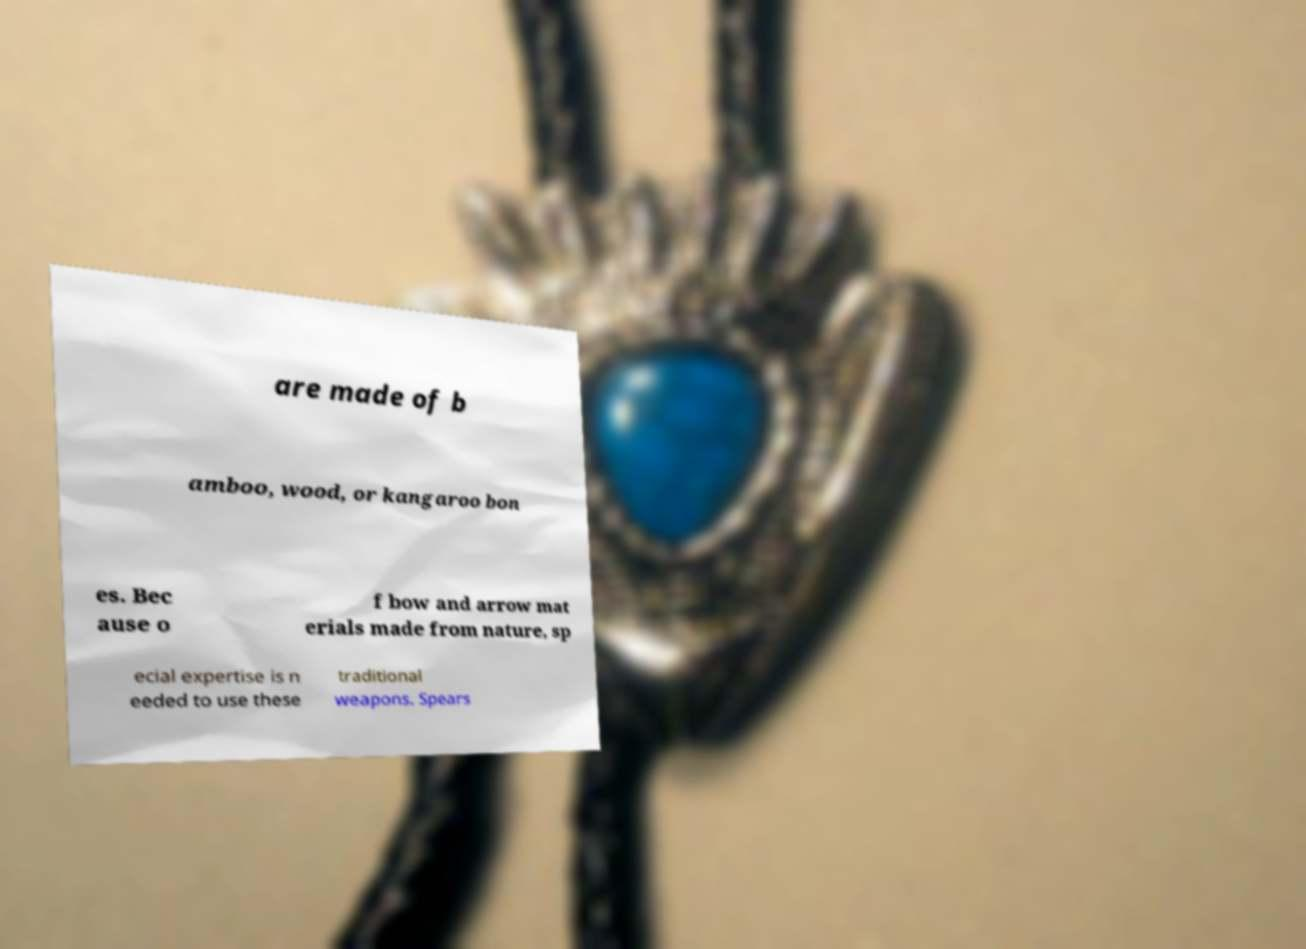There's text embedded in this image that I need extracted. Can you transcribe it verbatim? are made of b amboo, wood, or kangaroo bon es. Bec ause o f bow and arrow mat erials made from nature, sp ecial expertise is n eeded to use these traditional weapons. Spears 